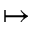<formula> <loc_0><loc_0><loc_500><loc_500>\mapsto</formula> 